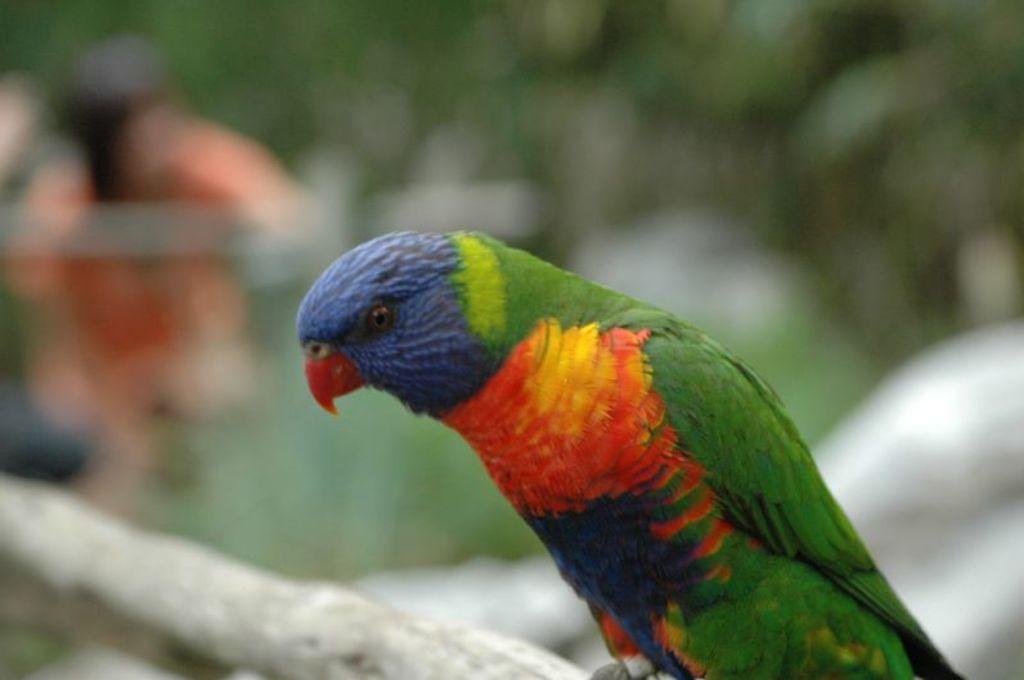Please provide a concise description of this image. In the center of the image there is a bird. The background of the image is blurry. 